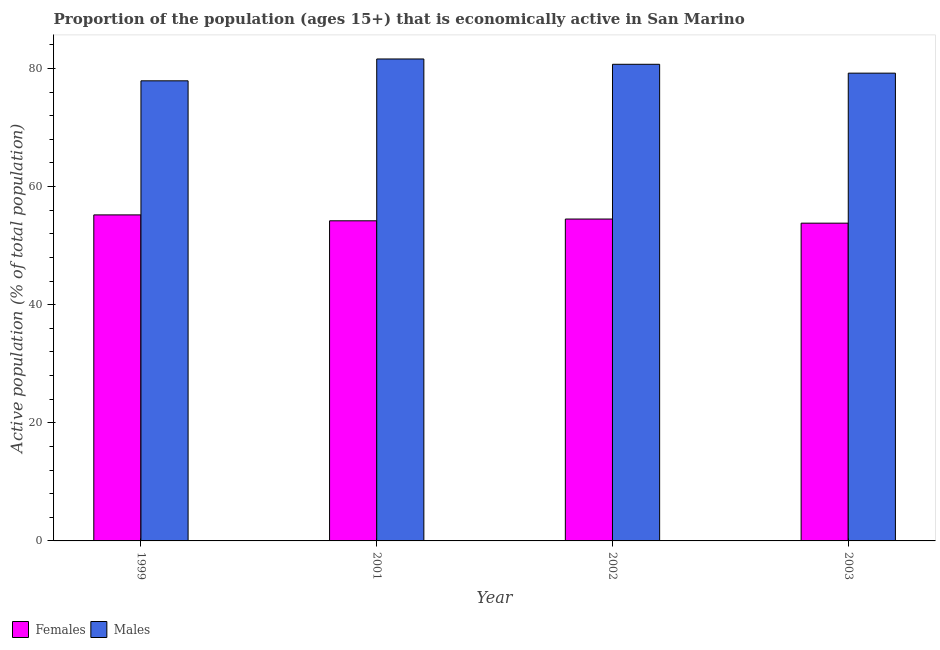How many different coloured bars are there?
Give a very brief answer. 2. How many groups of bars are there?
Ensure brevity in your answer.  4. What is the label of the 1st group of bars from the left?
Your response must be concise. 1999. What is the percentage of economically active female population in 2002?
Give a very brief answer. 54.5. Across all years, what is the maximum percentage of economically active female population?
Make the answer very short. 55.2. Across all years, what is the minimum percentage of economically active male population?
Offer a terse response. 77.9. In which year was the percentage of economically active female population maximum?
Provide a succinct answer. 1999. What is the total percentage of economically active female population in the graph?
Your response must be concise. 217.7. What is the difference between the percentage of economically active female population in 2001 and the percentage of economically active male population in 2002?
Offer a very short reply. -0.3. What is the average percentage of economically active male population per year?
Ensure brevity in your answer.  79.85. In how many years, is the percentage of economically active female population greater than 64 %?
Make the answer very short. 0. What is the ratio of the percentage of economically active female population in 2001 to that in 2002?
Your answer should be compact. 0.99. What is the difference between the highest and the second highest percentage of economically active female population?
Give a very brief answer. 0.7. What is the difference between the highest and the lowest percentage of economically active female population?
Provide a short and direct response. 1.4. In how many years, is the percentage of economically active female population greater than the average percentage of economically active female population taken over all years?
Provide a short and direct response. 2. What does the 1st bar from the left in 2001 represents?
Keep it short and to the point. Females. What does the 1st bar from the right in 2002 represents?
Provide a short and direct response. Males. How many bars are there?
Make the answer very short. 8. How many years are there in the graph?
Your answer should be very brief. 4. What is the difference between two consecutive major ticks on the Y-axis?
Ensure brevity in your answer.  20. Does the graph contain any zero values?
Your response must be concise. No. Does the graph contain grids?
Your answer should be compact. No. How are the legend labels stacked?
Keep it short and to the point. Horizontal. What is the title of the graph?
Give a very brief answer. Proportion of the population (ages 15+) that is economically active in San Marino. What is the label or title of the Y-axis?
Your answer should be compact. Active population (% of total population). What is the Active population (% of total population) in Females in 1999?
Offer a terse response. 55.2. What is the Active population (% of total population) in Males in 1999?
Give a very brief answer. 77.9. What is the Active population (% of total population) of Females in 2001?
Ensure brevity in your answer.  54.2. What is the Active population (% of total population) of Males in 2001?
Offer a very short reply. 81.6. What is the Active population (% of total population) of Females in 2002?
Ensure brevity in your answer.  54.5. What is the Active population (% of total population) in Males in 2002?
Give a very brief answer. 80.7. What is the Active population (% of total population) in Females in 2003?
Ensure brevity in your answer.  53.8. What is the Active population (% of total population) of Males in 2003?
Give a very brief answer. 79.2. Across all years, what is the maximum Active population (% of total population) in Females?
Give a very brief answer. 55.2. Across all years, what is the maximum Active population (% of total population) in Males?
Make the answer very short. 81.6. Across all years, what is the minimum Active population (% of total population) in Females?
Offer a terse response. 53.8. Across all years, what is the minimum Active population (% of total population) in Males?
Your response must be concise. 77.9. What is the total Active population (% of total population) in Females in the graph?
Provide a short and direct response. 217.7. What is the total Active population (% of total population) in Males in the graph?
Make the answer very short. 319.4. What is the difference between the Active population (% of total population) of Females in 1999 and that in 2001?
Provide a short and direct response. 1. What is the difference between the Active population (% of total population) in Males in 1999 and that in 2002?
Your answer should be compact. -2.8. What is the difference between the Active population (% of total population) in Males in 1999 and that in 2003?
Offer a terse response. -1.3. What is the difference between the Active population (% of total population) in Males in 2001 and that in 2002?
Offer a very short reply. 0.9. What is the difference between the Active population (% of total population) in Females in 2001 and that in 2003?
Your response must be concise. 0.4. What is the difference between the Active population (% of total population) in Males in 2001 and that in 2003?
Keep it short and to the point. 2.4. What is the difference between the Active population (% of total population) in Females in 2002 and that in 2003?
Keep it short and to the point. 0.7. What is the difference between the Active population (% of total population) in Males in 2002 and that in 2003?
Provide a short and direct response. 1.5. What is the difference between the Active population (% of total population) in Females in 1999 and the Active population (% of total population) in Males in 2001?
Provide a short and direct response. -26.4. What is the difference between the Active population (% of total population) of Females in 1999 and the Active population (% of total population) of Males in 2002?
Your answer should be compact. -25.5. What is the difference between the Active population (% of total population) in Females in 1999 and the Active population (% of total population) in Males in 2003?
Give a very brief answer. -24. What is the difference between the Active population (% of total population) of Females in 2001 and the Active population (% of total population) of Males in 2002?
Give a very brief answer. -26.5. What is the difference between the Active population (% of total population) in Females in 2002 and the Active population (% of total population) in Males in 2003?
Offer a terse response. -24.7. What is the average Active population (% of total population) of Females per year?
Offer a terse response. 54.42. What is the average Active population (% of total population) in Males per year?
Your answer should be very brief. 79.85. In the year 1999, what is the difference between the Active population (% of total population) in Females and Active population (% of total population) in Males?
Your answer should be very brief. -22.7. In the year 2001, what is the difference between the Active population (% of total population) of Females and Active population (% of total population) of Males?
Offer a very short reply. -27.4. In the year 2002, what is the difference between the Active population (% of total population) of Females and Active population (% of total population) of Males?
Give a very brief answer. -26.2. In the year 2003, what is the difference between the Active population (% of total population) of Females and Active population (% of total population) of Males?
Your answer should be very brief. -25.4. What is the ratio of the Active population (% of total population) of Females in 1999 to that in 2001?
Your answer should be compact. 1.02. What is the ratio of the Active population (% of total population) in Males in 1999 to that in 2001?
Provide a succinct answer. 0.95. What is the ratio of the Active population (% of total population) of Females in 1999 to that in 2002?
Offer a terse response. 1.01. What is the ratio of the Active population (% of total population) in Males in 1999 to that in 2002?
Give a very brief answer. 0.97. What is the ratio of the Active population (% of total population) in Females in 1999 to that in 2003?
Your answer should be very brief. 1.03. What is the ratio of the Active population (% of total population) in Males in 1999 to that in 2003?
Provide a short and direct response. 0.98. What is the ratio of the Active population (% of total population) of Males in 2001 to that in 2002?
Keep it short and to the point. 1.01. What is the ratio of the Active population (% of total population) of Females in 2001 to that in 2003?
Your response must be concise. 1.01. What is the ratio of the Active population (% of total population) of Males in 2001 to that in 2003?
Offer a terse response. 1.03. What is the ratio of the Active population (% of total population) in Males in 2002 to that in 2003?
Your answer should be very brief. 1.02. What is the difference between the highest and the second highest Active population (% of total population) of Males?
Keep it short and to the point. 0.9. 